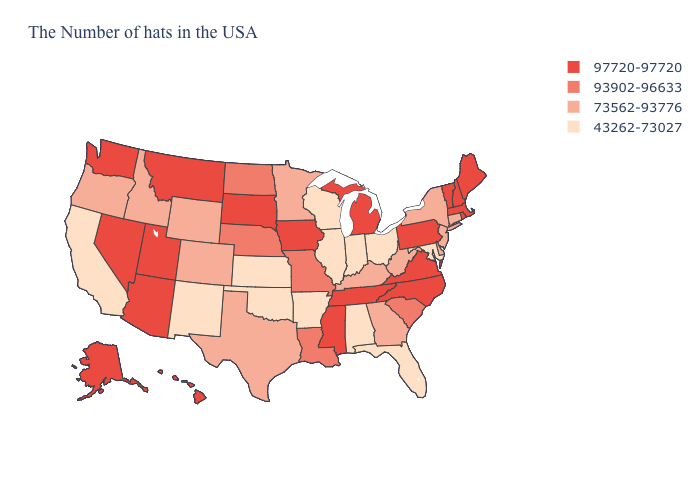Among the states that border Utah , which have the highest value?
Short answer required. Arizona, Nevada. Among the states that border North Carolina , which have the highest value?
Be succinct. Virginia, Tennessee. What is the value of Indiana?
Answer briefly. 43262-73027. Among the states that border Texas , does Arkansas have the lowest value?
Keep it brief. Yes. Among the states that border Georgia , does North Carolina have the lowest value?
Be succinct. No. What is the lowest value in states that border Nebraska?
Keep it brief. 43262-73027. What is the highest value in the West ?
Answer briefly. 97720-97720. What is the lowest value in the West?
Answer briefly. 43262-73027. Name the states that have a value in the range 43262-73027?
Quick response, please. Maryland, Ohio, Florida, Indiana, Alabama, Wisconsin, Illinois, Arkansas, Kansas, Oklahoma, New Mexico, California. What is the value of Massachusetts?
Write a very short answer. 97720-97720. Name the states that have a value in the range 43262-73027?
Write a very short answer. Maryland, Ohio, Florida, Indiana, Alabama, Wisconsin, Illinois, Arkansas, Kansas, Oklahoma, New Mexico, California. What is the value of Missouri?
Short answer required. 93902-96633. What is the highest value in states that border New Jersey?
Short answer required. 97720-97720. Among the states that border Connecticut , does New York have the lowest value?
Short answer required. Yes. What is the value of Colorado?
Short answer required. 73562-93776. 